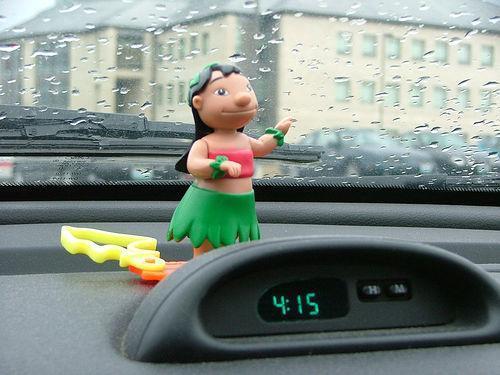How many objects are on the dashboard?
Give a very brief answer. 1. How many cars are in the picture?
Give a very brief answer. 1. 